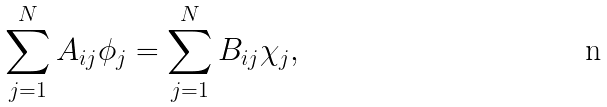<formula> <loc_0><loc_0><loc_500><loc_500>\sum _ { j = 1 } ^ { N } A _ { i j } \phi _ { j } & = \sum _ { j = 1 } ^ { N } B _ { i j } \chi _ { j } ,</formula> 